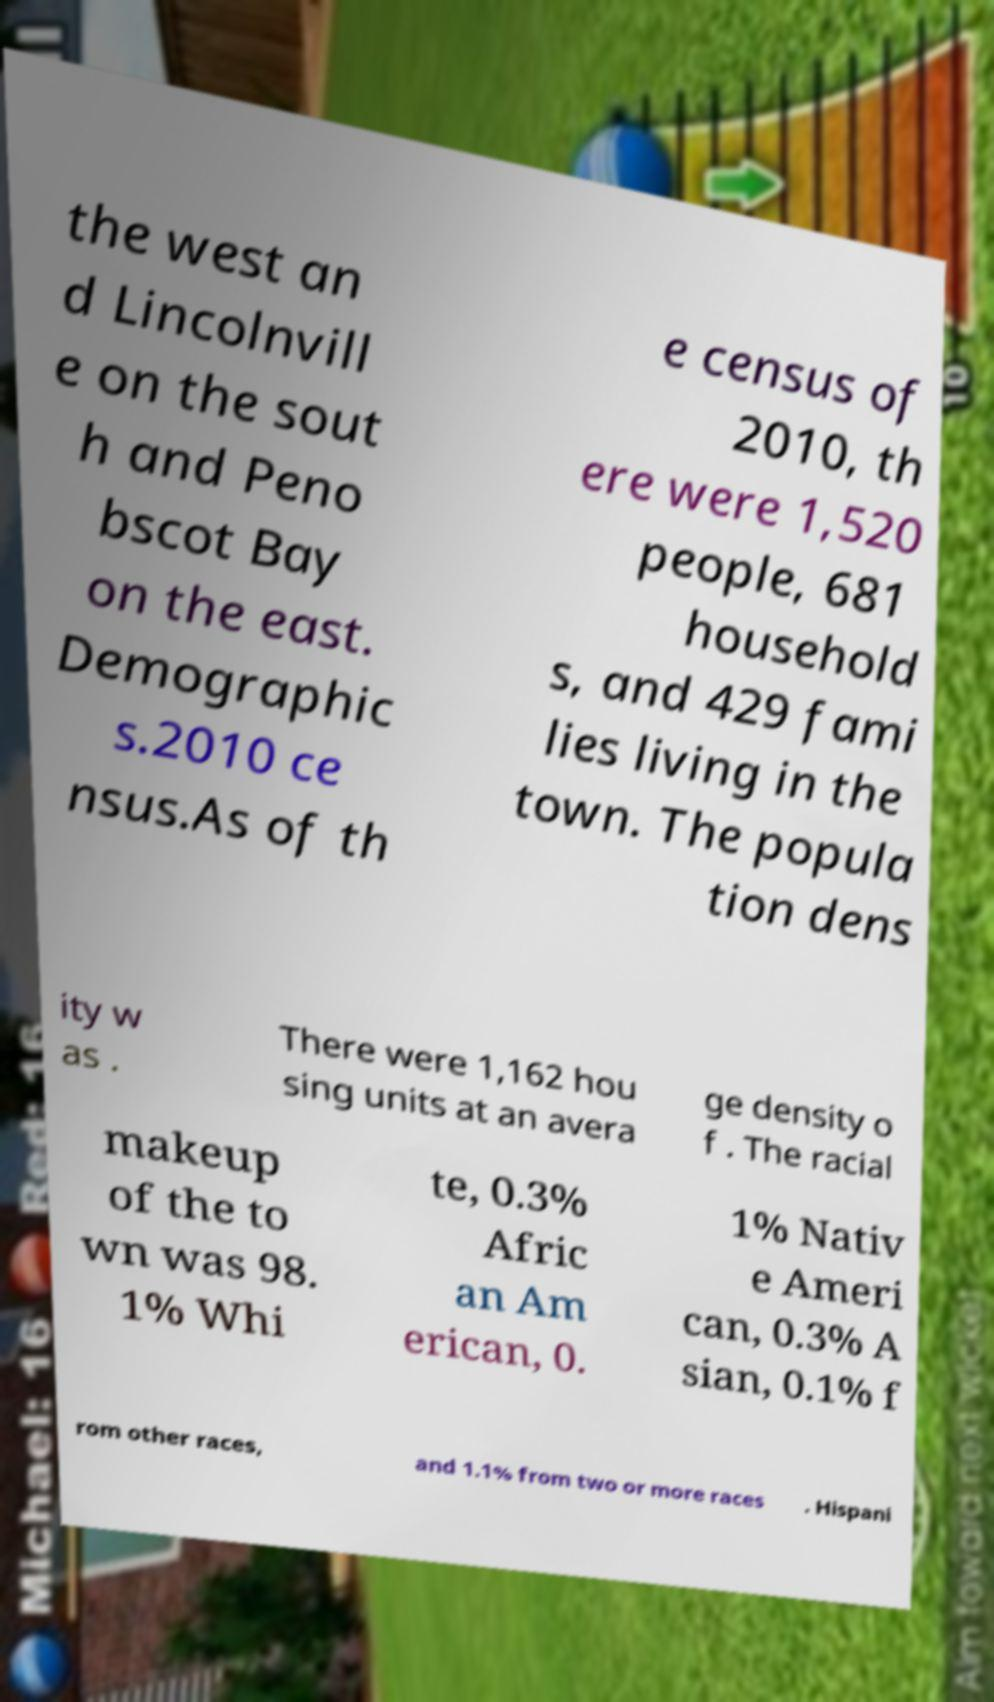Please identify and transcribe the text found in this image. the west an d Lincolnvill e on the sout h and Peno bscot Bay on the east. Demographic s.2010 ce nsus.As of th e census of 2010, th ere were 1,520 people, 681 household s, and 429 fami lies living in the town. The popula tion dens ity w as . There were 1,162 hou sing units at an avera ge density o f . The racial makeup of the to wn was 98. 1% Whi te, 0.3% Afric an Am erican, 0. 1% Nativ e Ameri can, 0.3% A sian, 0.1% f rom other races, and 1.1% from two or more races . Hispani 